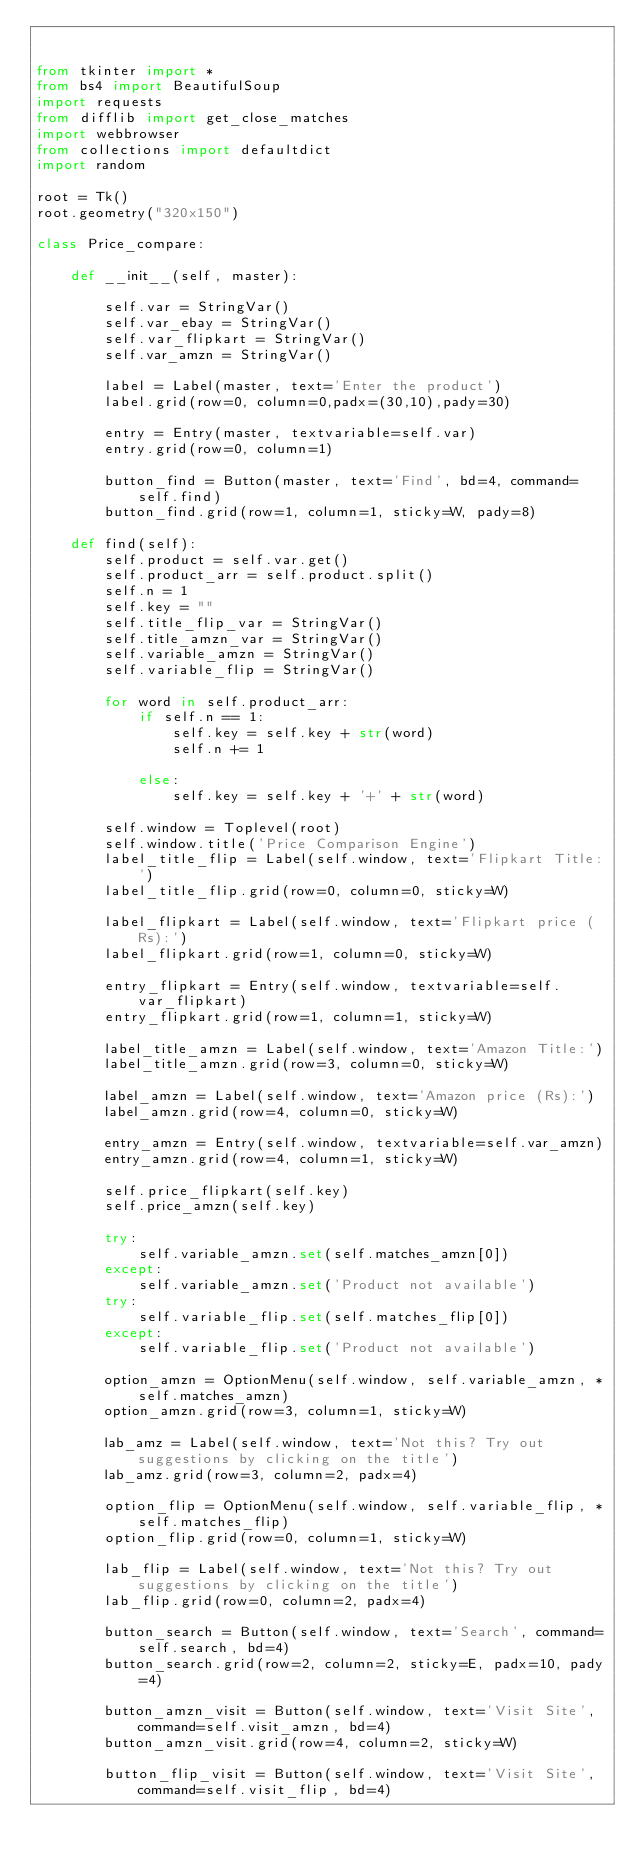Convert code to text. <code><loc_0><loc_0><loc_500><loc_500><_Python_>

from tkinter import *
from bs4 import BeautifulSoup
import requests
from difflib import get_close_matches
import webbrowser
from collections import defaultdict
import random

root = Tk()
root.geometry("320x150")

class Price_compare:

    def __init__(self, master):
        
        self.var = StringVar()
        self.var_ebay = StringVar()
        self.var_flipkart = StringVar()
        self.var_amzn = StringVar()

        label = Label(master, text='Enter the product')
        label.grid(row=0, column=0,padx=(30,10),pady=30)

        entry = Entry(master, textvariable=self.var)
        entry.grid(row=0, column=1)

        button_find = Button(master, text='Find', bd=4, command=self.find)
        button_find.grid(row=1, column=1, sticky=W, pady=8)

    def find(self):
        self.product = self.var.get()
        self.product_arr = self.product.split()
        self.n = 1
        self.key = ""
        self.title_flip_var = StringVar()
        self.title_amzn_var = StringVar()
        self.variable_amzn = StringVar()
        self.variable_flip = StringVar()

        for word in self.product_arr:
            if self.n == 1:
                self.key = self.key + str(word)
                self.n += 1

            else:
                self.key = self.key + '+' + str(word)

        self.window = Toplevel(root)
        self.window.title('Price Comparison Engine')
        label_title_flip = Label(self.window, text='Flipkart Title:')
        label_title_flip.grid(row=0, column=0, sticky=W)

        label_flipkart = Label(self.window, text='Flipkart price (Rs):')
        label_flipkart.grid(row=1, column=0, sticky=W)

        entry_flipkart = Entry(self.window, textvariable=self.var_flipkart)
        entry_flipkart.grid(row=1, column=1, sticky=W)

        label_title_amzn = Label(self.window, text='Amazon Title:')
        label_title_amzn.grid(row=3, column=0, sticky=W)

        label_amzn = Label(self.window, text='Amazon price (Rs):')
        label_amzn.grid(row=4, column=0, sticky=W)

        entry_amzn = Entry(self.window, textvariable=self.var_amzn)
        entry_amzn.grid(row=4, column=1, sticky=W)

        self.price_flipkart(self.key)
        self.price_amzn(self.key)

        try:
            self.variable_amzn.set(self.matches_amzn[0])
        except:
            self.variable_amzn.set('Product not available')
        try:
            self.variable_flip.set(self.matches_flip[0])
        except:
            self.variable_flip.set('Product not available')

        option_amzn = OptionMenu(self.window, self.variable_amzn, *self.matches_amzn)
        option_amzn.grid(row=3, column=1, sticky=W)

        lab_amz = Label(self.window, text='Not this? Try out suggestions by clicking on the title')
        lab_amz.grid(row=3, column=2, padx=4)

        option_flip = OptionMenu(self.window, self.variable_flip, *self.matches_flip)
        option_flip.grid(row=0, column=1, sticky=W)

        lab_flip = Label(self.window, text='Not this? Try out suggestions by clicking on the title')
        lab_flip.grid(row=0, column=2, padx=4)

        button_search = Button(self.window, text='Search', command=self.search, bd=4)
        button_search.grid(row=2, column=2, sticky=E, padx=10, pady=4)

        button_amzn_visit = Button(self.window, text='Visit Site', command=self.visit_amzn, bd=4)
        button_amzn_visit.grid(row=4, column=2, sticky=W)

        button_flip_visit = Button(self.window, text='Visit Site', command=self.visit_flip, bd=4)</code> 